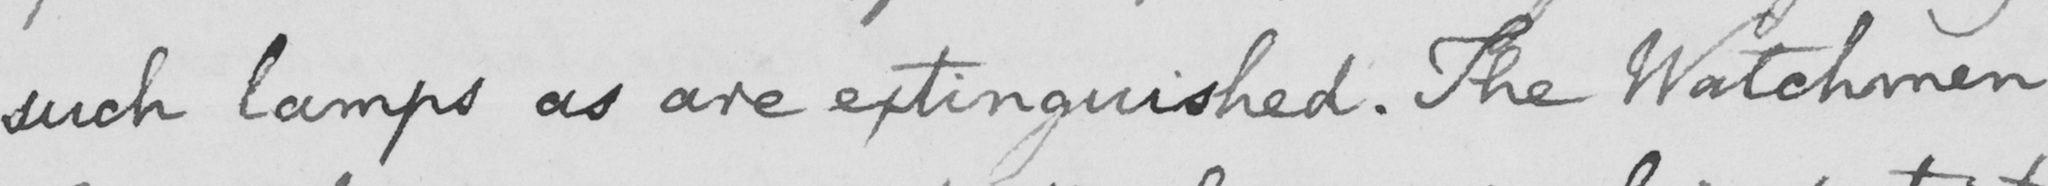What does this handwritten line say? such lamps as are extinguished . The Watchmen 